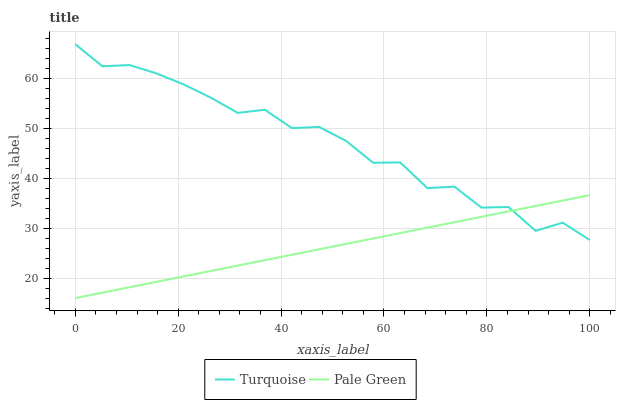Does Pale Green have the maximum area under the curve?
Answer yes or no. No. Is Pale Green the roughest?
Answer yes or no. No. Does Pale Green have the highest value?
Answer yes or no. No. 